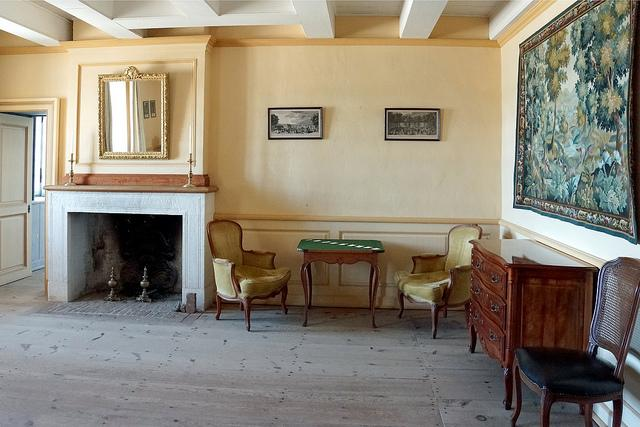Where are the candles placed in the room?

Choices:
A) mantle
B) table
C) dresser
D) floor mantle 